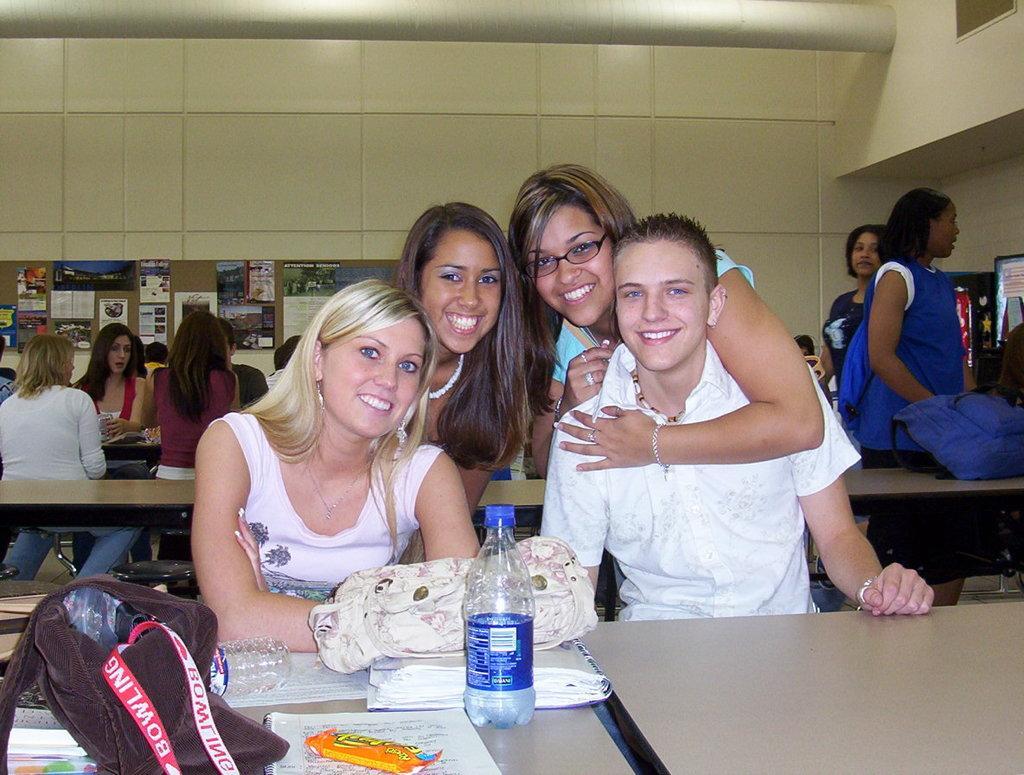How would you summarize this image in a sentence or two? In this image there is a bag, papers, books, bottles and some objects on the table, there are group of people standing and sitting on the benches,tables, papers stick to the board which is on the wall. 